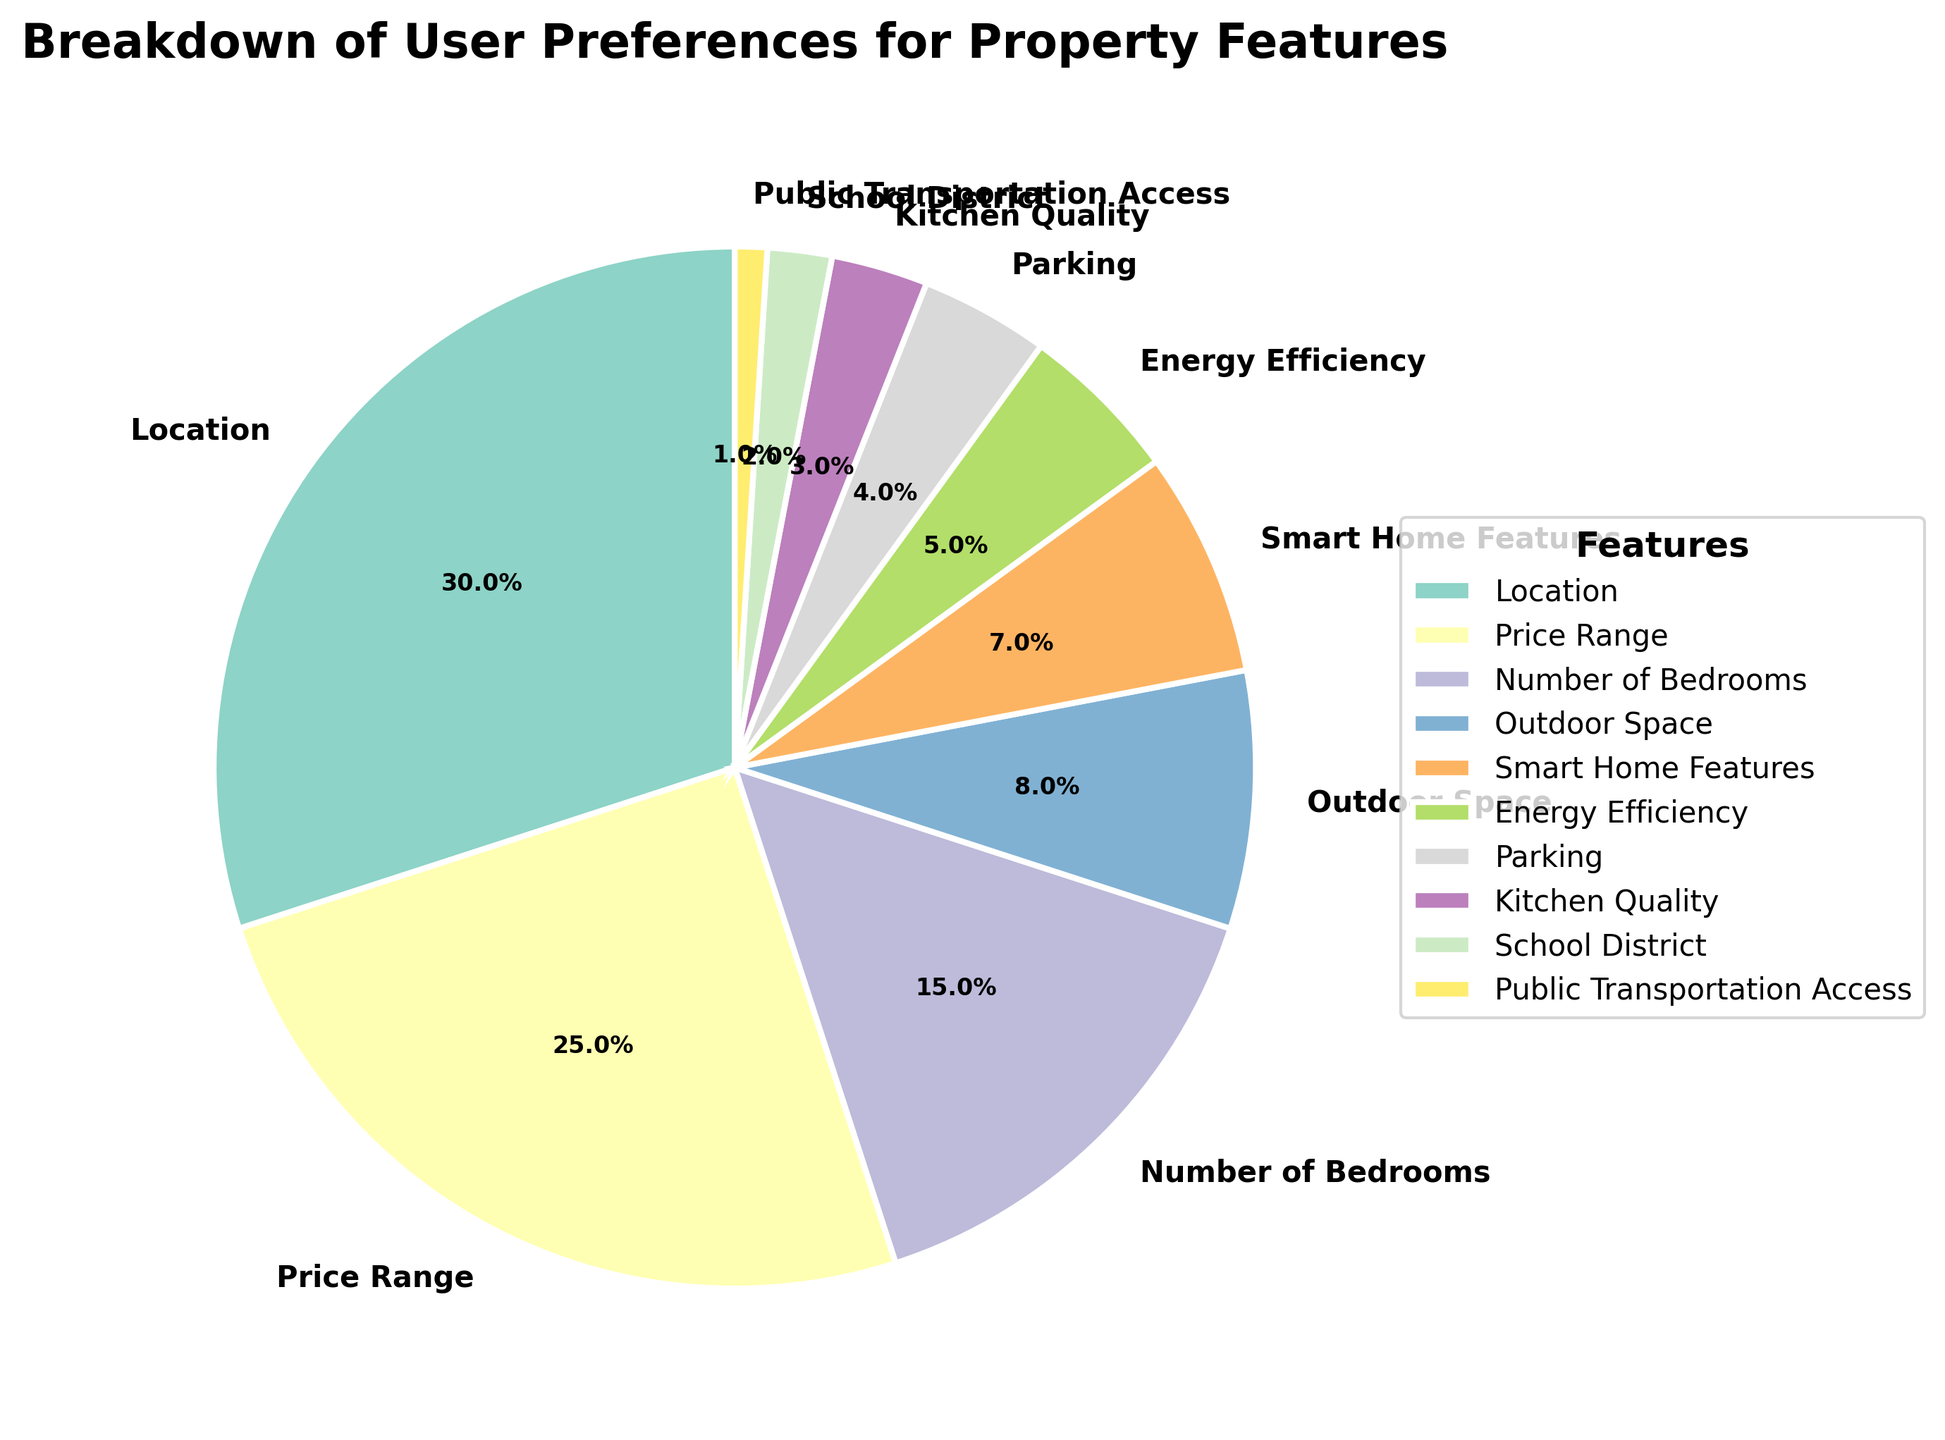What is the most preferred property feature among users? The largest segment in the pie chart represents the most preferred property feature. The segment labeled "Location" has the highest percentage, which is 30%.
Answer: Location How many property features have a preference percentage equal to or greater than 10%? By observing the pie chart, count the segments that have a percentage equal to or greater than 10%. The features are "Location" (30%), "Price Range" (25%), and "Number of Bedrooms" (15%). There are three such features.
Answer: 3 Which feature is less preferred: "Energy Efficiency" or "Parking"? Compare the slice sizes of "Energy Efficiency" and "Parking". "Energy Efficiency" has a percentage of 5%, while "Parking" has a percentage of 4%. "Parking" is less preferred.
Answer: Parking What is the total percentage of preferences for features related to 'Smart Home Features' and 'Kitchen Quality'? Sum the percentages of "Smart Home Features" (7%) and "Kitchen Quality" (3%). The total is 7% + 3% = 10%.
Answer: 10% Does the preference for "School District" exceed that for "Public Transportation Access"? Compare the percentages of "School District" and "Public Transportation Access". "School District" has 2%, while "Public Transportation Access" has 1%. "School District" has a higher preference.
Answer: Yes What is the combined percentage of preference for features related to outdoor activities (Outdoor Space, Public Transportation Access)? Sum the percentages of "Outdoor Space" (8%) and "Public Transportation Access" (1%). The total is 8% + 1% = 9%.
Answer: 9% Which feature has a preference percentage closest to 5%? Observe the percentages and identify the one closest to 5%. "Energy Efficiency" has a percentage of 5%, which matches exactly.
Answer: Energy Efficiency Rank the top three property features based on user preferences. By examining the largest slices, identify the three largest percentages: "Location" (30%), "Price Range" (25%), and "Number of Bedrooms" (15%). Rank them in descending order.
Answer: Location, Price Range, Number of Bedrooms Are there more features with preference percentages above or below 5%? Count the features above 5% and those below 5%. Above 5%: "Location" (30%), "Price Range" (25%), "Number of Bedrooms" (15%), "Outdoor Space" (8%), "Smart Home Features" (7%). Below 5%: "Energy Efficiency" (5%), "Parking" (4%), "Kitchen Quality" (3%), "School District" (2%), and "Public Transportation Access" (1%). Both categories have five features, so they are equal.
Answer: Equal Which property feature occupies the smallest segment in the pie chart? Find the smallest segment in the pie chart. The feature "Public Transportation Access" has the smallest percentage, which is 1%.
Answer: Public Transportation Access 